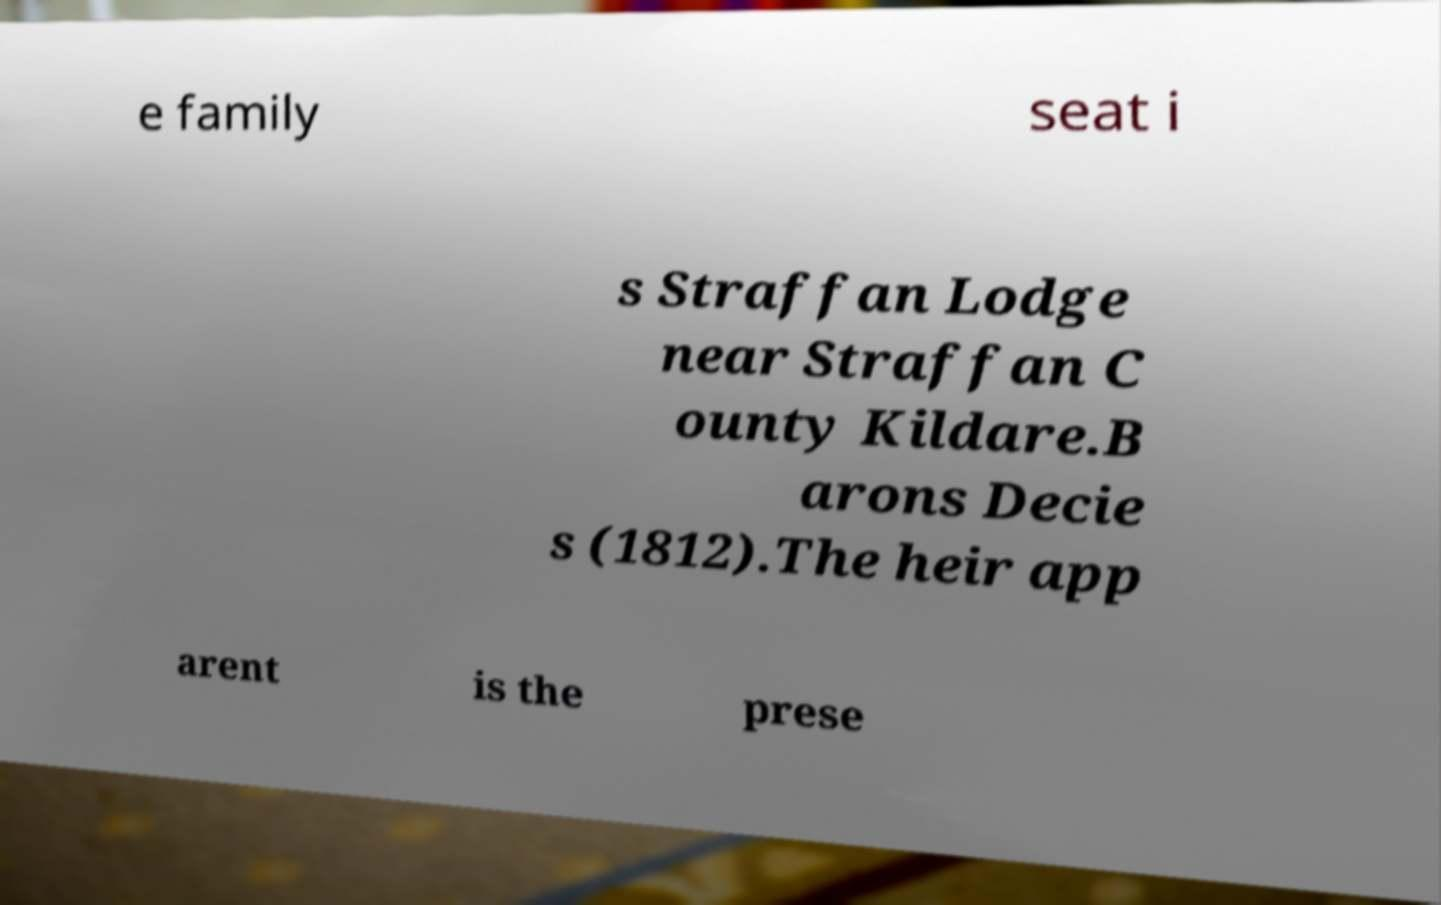Can you accurately transcribe the text from the provided image for me? e family seat i s Straffan Lodge near Straffan C ounty Kildare.B arons Decie s (1812).The heir app arent is the prese 